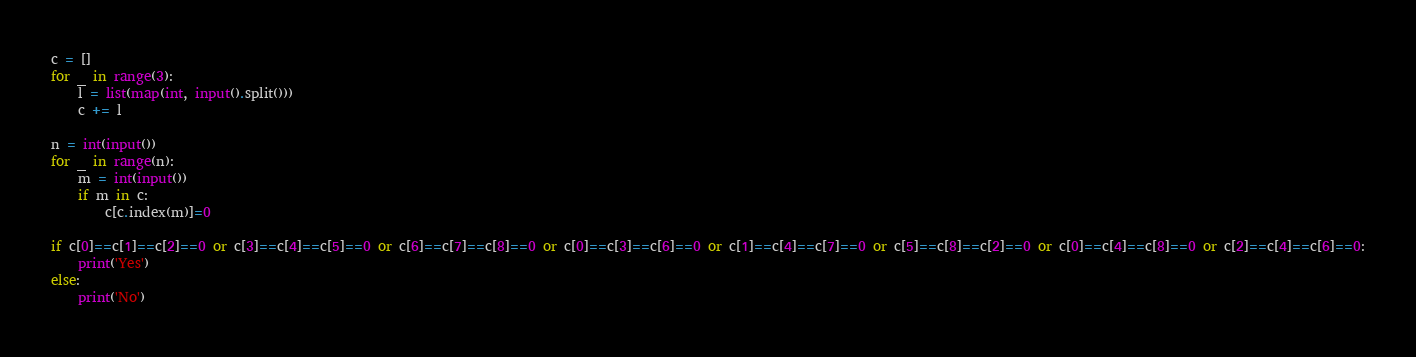Convert code to text. <code><loc_0><loc_0><loc_500><loc_500><_Python_>c = []
for _ in range(3):
    l = list(map(int, input().split()))
    c += l

n = int(input())
for _ in range(n):
    m = int(input())
    if m in c:
        c[c.index(m)]=0

if c[0]==c[1]==c[2]==0 or c[3]==c[4]==c[5]==0 or c[6]==c[7]==c[8]==0 or c[0]==c[3]==c[6]==0 or c[1]==c[4]==c[7]==0 or c[5]==c[8]==c[2]==0 or c[0]==c[4]==c[8]==0 or c[2]==c[4]==c[6]==0:
    print('Yes')
else:
    print('No')</code> 